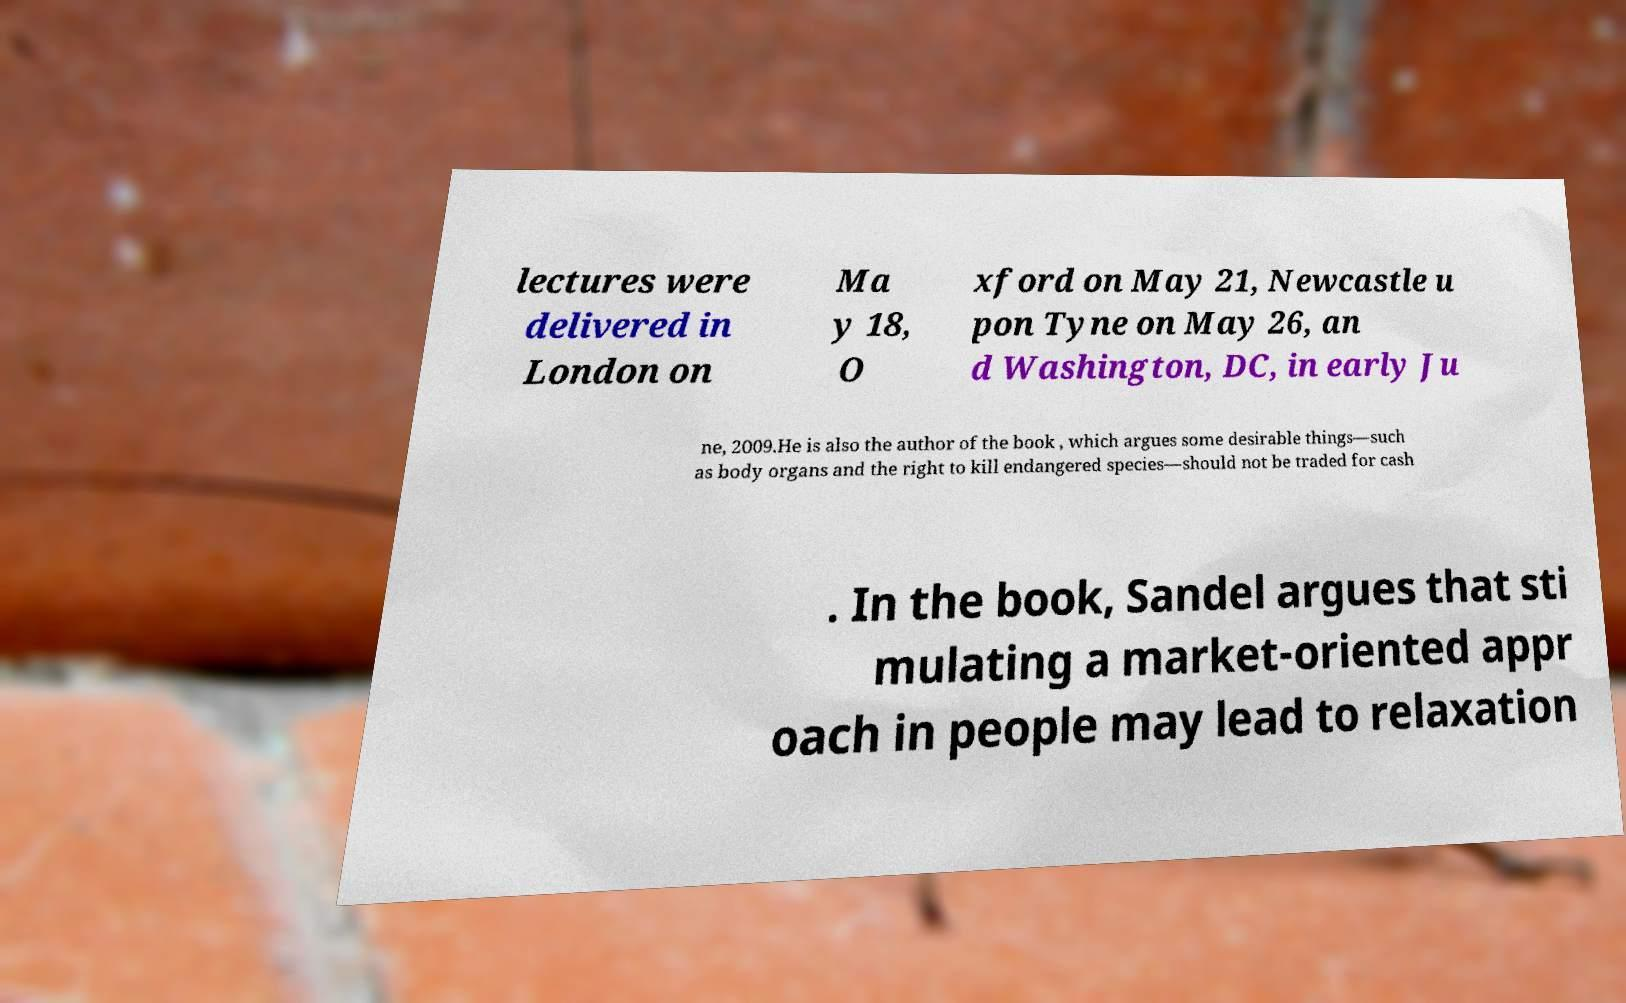Could you extract and type out the text from this image? lectures were delivered in London on Ma y 18, O xford on May 21, Newcastle u pon Tyne on May 26, an d Washington, DC, in early Ju ne, 2009.He is also the author of the book , which argues some desirable things—such as body organs and the right to kill endangered species—should not be traded for cash . In the book, Sandel argues that sti mulating a market-oriented appr oach in people may lead to relaxation 